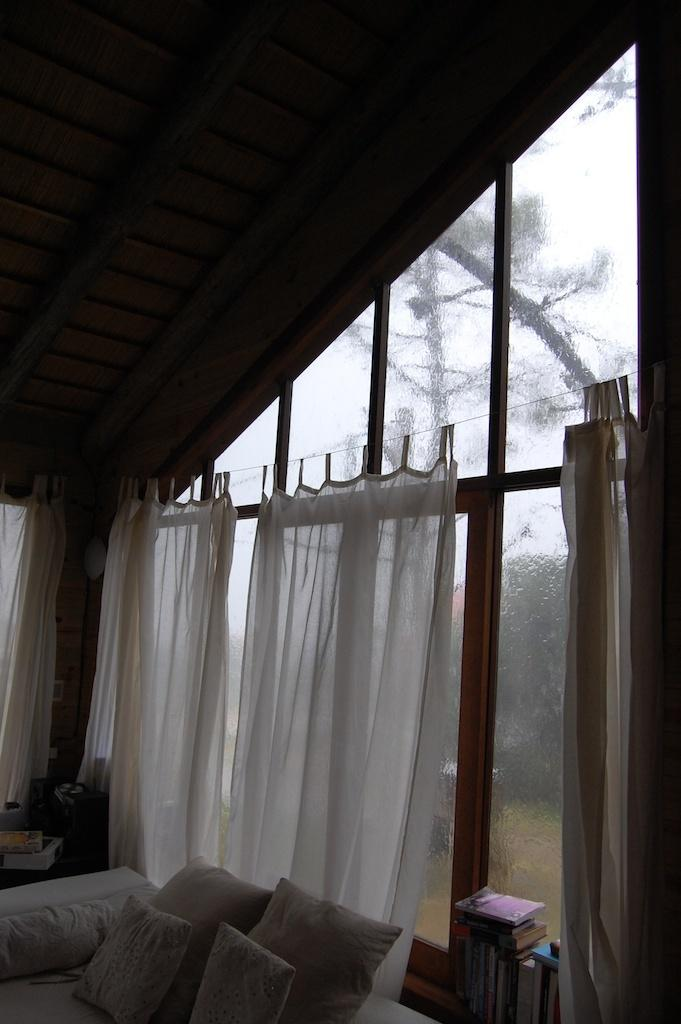What objects can be seen on the left side of the image? There are pillows on the left side of the image. What objects can be seen on the right side of the image? There are books on the right side of the image. What architectural features are visible in the image? There are windows and a roof visible in the image. What type of window treatment is present in the image? There are curtains associated with the windows. What day of the week is depicted in the image? The image does not depict a specific day of the week; it only shows pillows, books, windows, curtains, and a roof. 